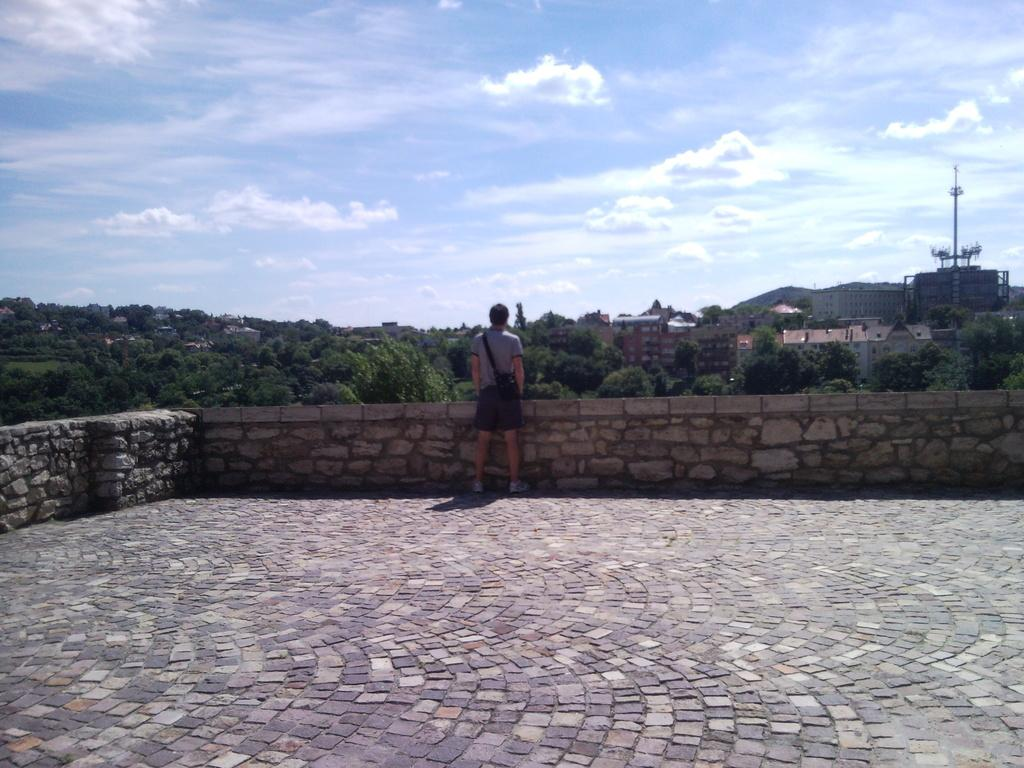What is the main subject in the image? There is a person standing in the image. What can be seen in the background of the image? There are boundary walls, trees, houses, and an electrical pole in the image. What is visible above the objects in the image? The sky is visible in the image. Where is the carriage located in the image? There is no carriage present in the image. What type of cellar can be seen in the image? There is no cellar present in the image. 